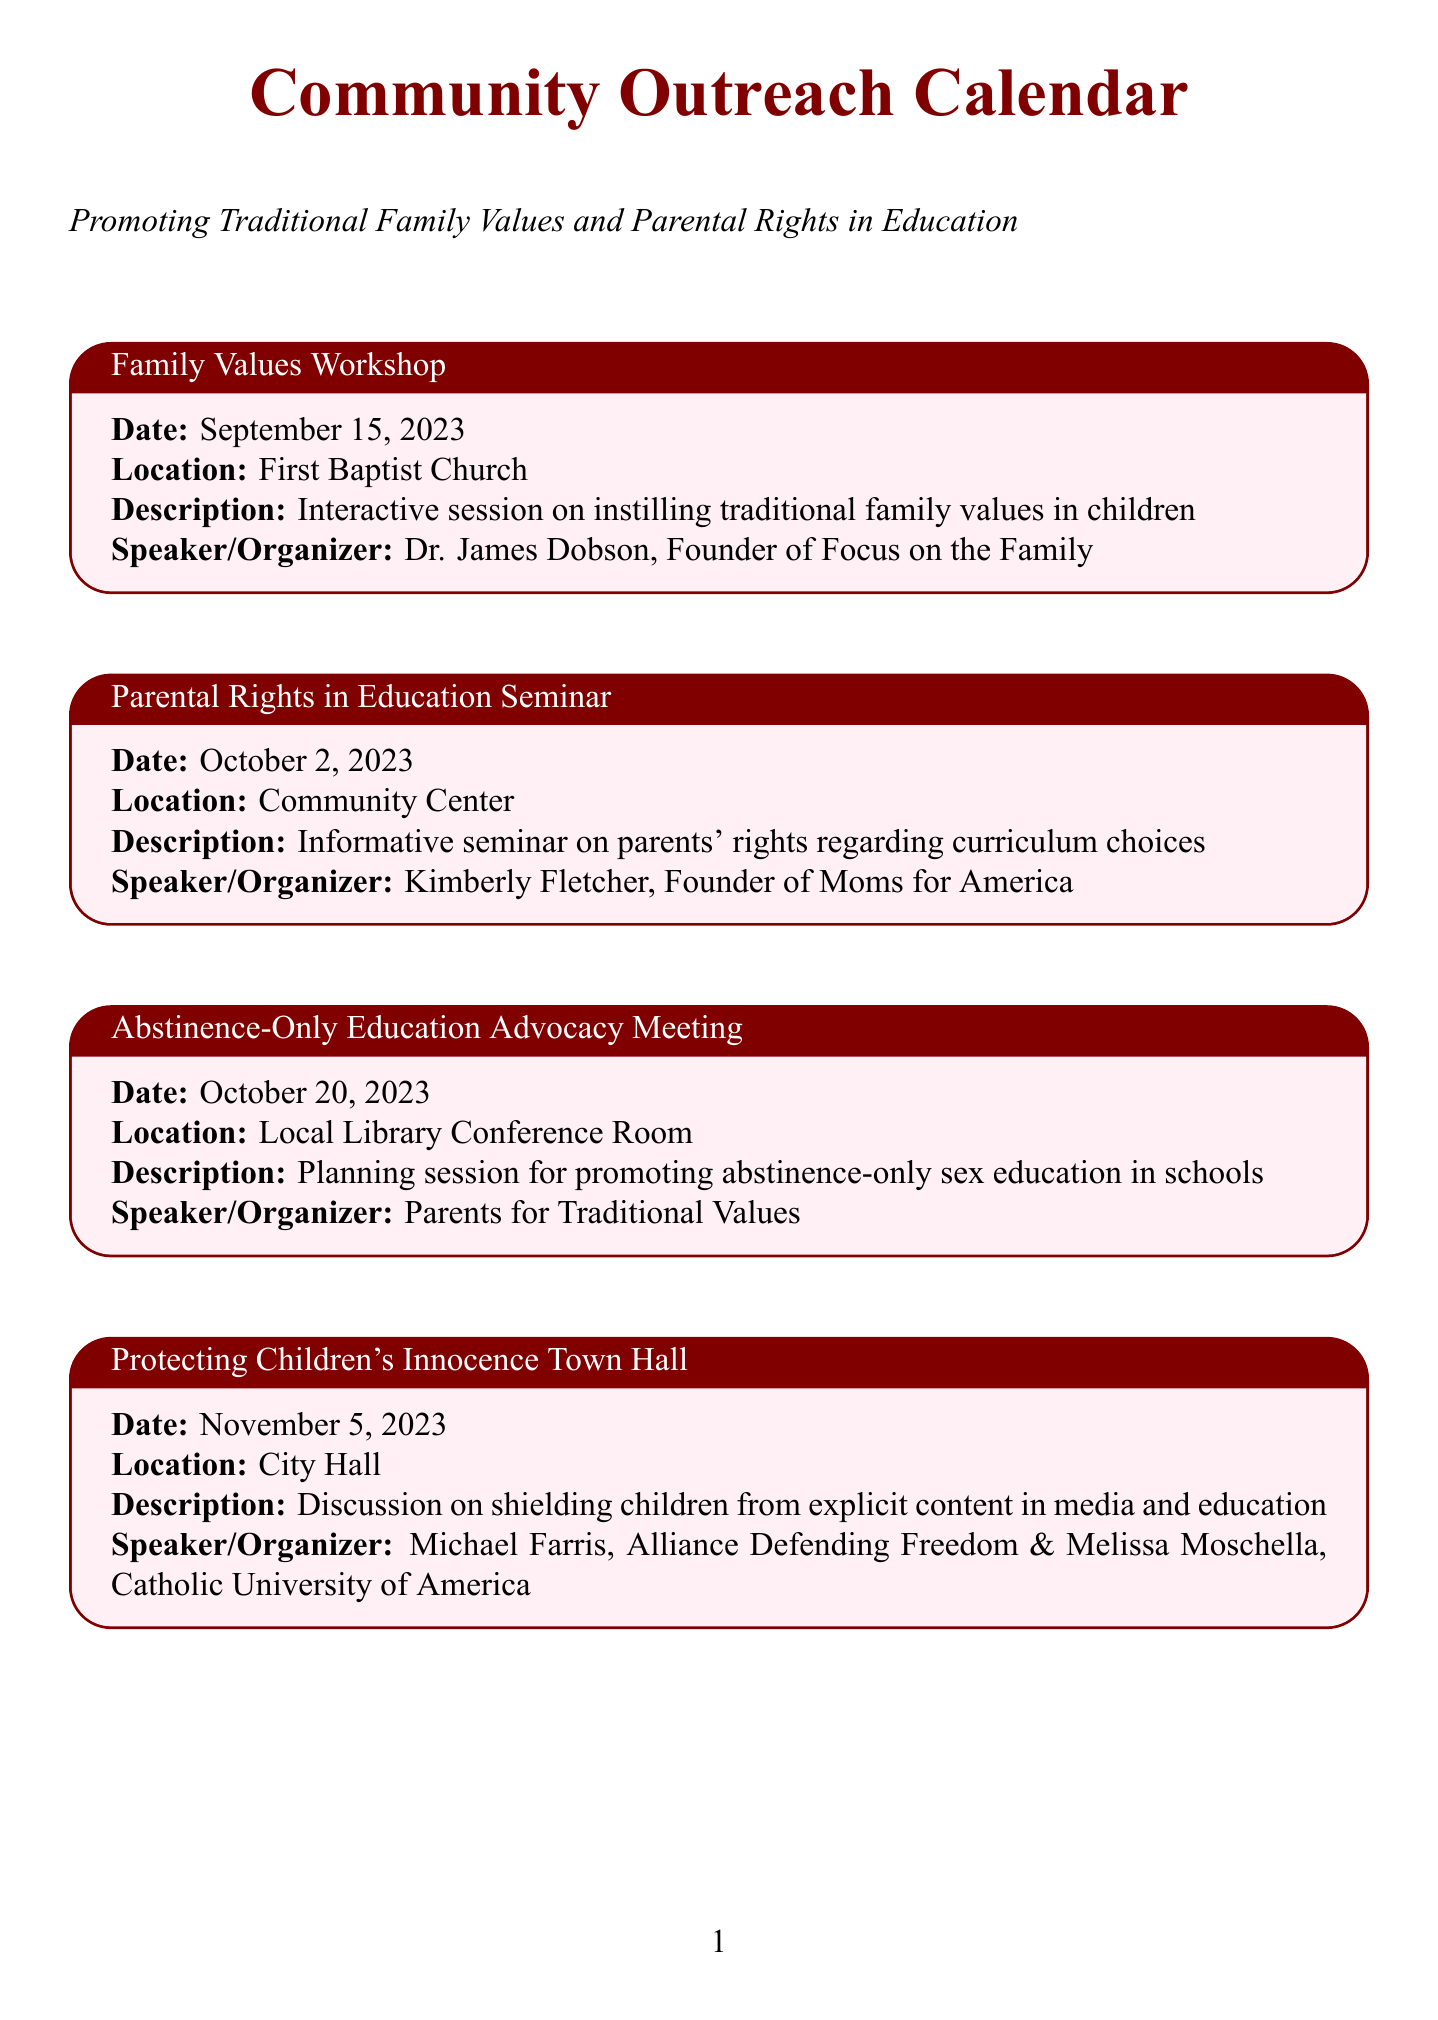What is the name of the first event? The first event listed in the document is the "Family Values Workshop."
Answer: Family Values Workshop Who is the speaker at the "Parental Rights in Education Seminar"? The speaker at this seminar is Kimberly Fletcher.
Answer: Kimberly Fletcher What date is the "Abstinence-Only Education Advocacy Meeting" scheduled for? This meeting is scheduled for October 20, 2023.
Answer: October 20, 2023 Which location will host the "Protecting Children's Innocence Town Hall"? The town hall will be held at City Hall.
Answer: City Hall What is the focus of the "Faith-Based Sex Education Workshop"? The focus is on teaching sex education from a religious perspective.
Answer: Teaching sex education from a religious perspective What type of event is scheduled for February 8, 2024? This is a "Family Movie Night."
Answer: Family Movie Night Who leads the "Prayers for Our Schools Vigil"? The vigil is led by Pastor John MacArthur.
Answer: Pastor John MacArthur How many speakers are at the "Protecting Children's Innocence Town Hall"? There are two speakers at this event.
Answer: Two What organization is involved in the "Homeschooling Information Fair"? The organizer is the Home School Legal Defense Association.
Answer: Home School Legal Defense Association 